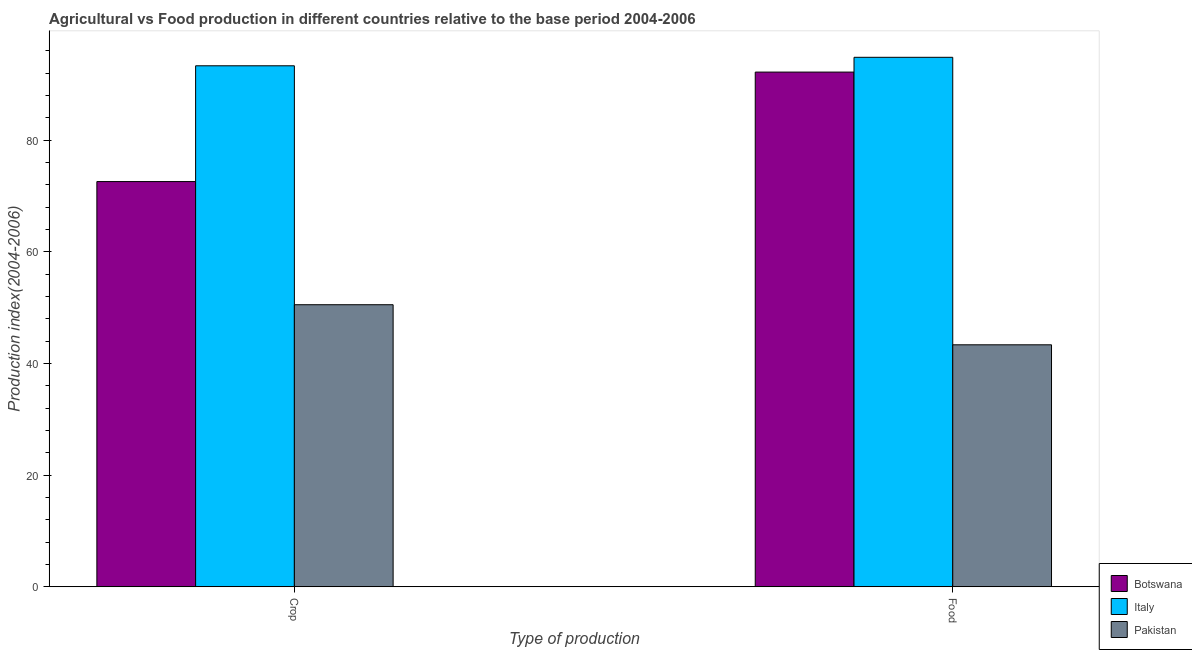How many groups of bars are there?
Ensure brevity in your answer.  2. Are the number of bars on each tick of the X-axis equal?
Offer a very short reply. Yes. How many bars are there on the 1st tick from the right?
Ensure brevity in your answer.  3. What is the label of the 1st group of bars from the left?
Give a very brief answer. Crop. What is the crop production index in Pakistan?
Make the answer very short. 50.52. Across all countries, what is the maximum food production index?
Your answer should be very brief. 94.84. Across all countries, what is the minimum food production index?
Provide a short and direct response. 43.34. In which country was the food production index minimum?
Offer a very short reply. Pakistan. What is the total crop production index in the graph?
Provide a short and direct response. 216.42. What is the difference between the food production index in Botswana and that in Pakistan?
Offer a terse response. 48.85. What is the difference between the food production index in Pakistan and the crop production index in Italy?
Offer a terse response. -49.98. What is the average food production index per country?
Provide a succinct answer. 76.79. What is the difference between the crop production index and food production index in Italy?
Keep it short and to the point. -1.52. In how many countries, is the food production index greater than 88 ?
Your answer should be compact. 2. What is the ratio of the crop production index in Botswana to that in Italy?
Make the answer very short. 0.78. Is the crop production index in Botswana less than that in Pakistan?
Offer a very short reply. No. In how many countries, is the food production index greater than the average food production index taken over all countries?
Your answer should be compact. 2. What does the 1st bar from the left in Crop represents?
Ensure brevity in your answer.  Botswana. What does the 1st bar from the right in Crop represents?
Provide a short and direct response. Pakistan. How many bars are there?
Your response must be concise. 6. How many countries are there in the graph?
Ensure brevity in your answer.  3. Does the graph contain grids?
Provide a succinct answer. No. How many legend labels are there?
Offer a very short reply. 3. How are the legend labels stacked?
Your response must be concise. Vertical. What is the title of the graph?
Your answer should be very brief. Agricultural vs Food production in different countries relative to the base period 2004-2006. What is the label or title of the X-axis?
Provide a short and direct response. Type of production. What is the label or title of the Y-axis?
Make the answer very short. Production index(2004-2006). What is the Production index(2004-2006) in Botswana in Crop?
Offer a very short reply. 72.58. What is the Production index(2004-2006) in Italy in Crop?
Make the answer very short. 93.32. What is the Production index(2004-2006) in Pakistan in Crop?
Make the answer very short. 50.52. What is the Production index(2004-2006) in Botswana in Food?
Offer a very short reply. 92.19. What is the Production index(2004-2006) in Italy in Food?
Provide a succinct answer. 94.84. What is the Production index(2004-2006) of Pakistan in Food?
Keep it short and to the point. 43.34. Across all Type of production, what is the maximum Production index(2004-2006) in Botswana?
Provide a short and direct response. 92.19. Across all Type of production, what is the maximum Production index(2004-2006) in Italy?
Give a very brief answer. 94.84. Across all Type of production, what is the maximum Production index(2004-2006) of Pakistan?
Provide a succinct answer. 50.52. Across all Type of production, what is the minimum Production index(2004-2006) of Botswana?
Your answer should be compact. 72.58. Across all Type of production, what is the minimum Production index(2004-2006) of Italy?
Ensure brevity in your answer.  93.32. Across all Type of production, what is the minimum Production index(2004-2006) in Pakistan?
Make the answer very short. 43.34. What is the total Production index(2004-2006) in Botswana in the graph?
Keep it short and to the point. 164.77. What is the total Production index(2004-2006) in Italy in the graph?
Provide a succinct answer. 188.16. What is the total Production index(2004-2006) of Pakistan in the graph?
Give a very brief answer. 93.86. What is the difference between the Production index(2004-2006) in Botswana in Crop and that in Food?
Your response must be concise. -19.61. What is the difference between the Production index(2004-2006) in Italy in Crop and that in Food?
Give a very brief answer. -1.52. What is the difference between the Production index(2004-2006) in Pakistan in Crop and that in Food?
Ensure brevity in your answer.  7.18. What is the difference between the Production index(2004-2006) in Botswana in Crop and the Production index(2004-2006) in Italy in Food?
Ensure brevity in your answer.  -22.26. What is the difference between the Production index(2004-2006) in Botswana in Crop and the Production index(2004-2006) in Pakistan in Food?
Offer a very short reply. 29.24. What is the difference between the Production index(2004-2006) of Italy in Crop and the Production index(2004-2006) of Pakistan in Food?
Make the answer very short. 49.98. What is the average Production index(2004-2006) of Botswana per Type of production?
Ensure brevity in your answer.  82.39. What is the average Production index(2004-2006) of Italy per Type of production?
Keep it short and to the point. 94.08. What is the average Production index(2004-2006) of Pakistan per Type of production?
Offer a terse response. 46.93. What is the difference between the Production index(2004-2006) of Botswana and Production index(2004-2006) of Italy in Crop?
Make the answer very short. -20.74. What is the difference between the Production index(2004-2006) in Botswana and Production index(2004-2006) in Pakistan in Crop?
Your answer should be compact. 22.06. What is the difference between the Production index(2004-2006) in Italy and Production index(2004-2006) in Pakistan in Crop?
Provide a short and direct response. 42.8. What is the difference between the Production index(2004-2006) in Botswana and Production index(2004-2006) in Italy in Food?
Make the answer very short. -2.65. What is the difference between the Production index(2004-2006) of Botswana and Production index(2004-2006) of Pakistan in Food?
Provide a short and direct response. 48.85. What is the difference between the Production index(2004-2006) in Italy and Production index(2004-2006) in Pakistan in Food?
Make the answer very short. 51.5. What is the ratio of the Production index(2004-2006) of Botswana in Crop to that in Food?
Offer a very short reply. 0.79. What is the ratio of the Production index(2004-2006) in Italy in Crop to that in Food?
Your answer should be compact. 0.98. What is the ratio of the Production index(2004-2006) of Pakistan in Crop to that in Food?
Offer a very short reply. 1.17. What is the difference between the highest and the second highest Production index(2004-2006) in Botswana?
Keep it short and to the point. 19.61. What is the difference between the highest and the second highest Production index(2004-2006) in Italy?
Your answer should be very brief. 1.52. What is the difference between the highest and the second highest Production index(2004-2006) of Pakistan?
Your response must be concise. 7.18. What is the difference between the highest and the lowest Production index(2004-2006) in Botswana?
Offer a terse response. 19.61. What is the difference between the highest and the lowest Production index(2004-2006) in Italy?
Provide a short and direct response. 1.52. What is the difference between the highest and the lowest Production index(2004-2006) of Pakistan?
Provide a short and direct response. 7.18. 